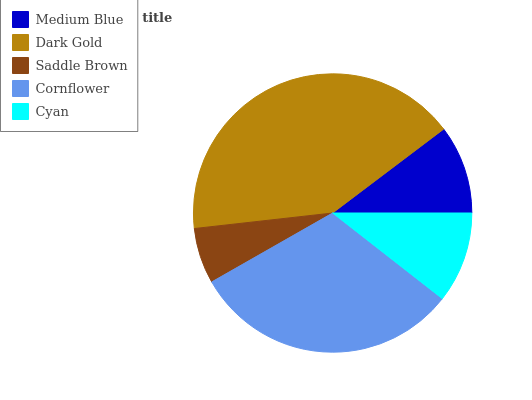Is Saddle Brown the minimum?
Answer yes or no. Yes. Is Dark Gold the maximum?
Answer yes or no. Yes. Is Dark Gold the minimum?
Answer yes or no. No. Is Saddle Brown the maximum?
Answer yes or no. No. Is Dark Gold greater than Saddle Brown?
Answer yes or no. Yes. Is Saddle Brown less than Dark Gold?
Answer yes or no. Yes. Is Saddle Brown greater than Dark Gold?
Answer yes or no. No. Is Dark Gold less than Saddle Brown?
Answer yes or no. No. Is Cyan the high median?
Answer yes or no. Yes. Is Cyan the low median?
Answer yes or no. Yes. Is Saddle Brown the high median?
Answer yes or no. No. Is Medium Blue the low median?
Answer yes or no. No. 